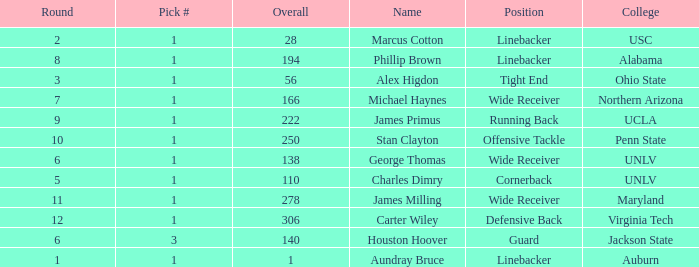In what Round with an Overall greater than 306 was the pick from the College of Virginia Tech? 0.0. 